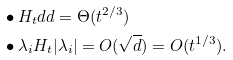Convert formula to latex. <formula><loc_0><loc_0><loc_500><loc_500>& \bullet H _ { t } d d = \Theta ( t ^ { 2 / 3 } ) \\ & \bullet \lambda _ { i } H _ { t } | \lambda _ { i } | = O ( \sqrt { d } ) = O ( t ^ { 1 / 3 } ) .</formula> 